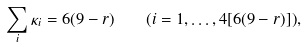<formula> <loc_0><loc_0><loc_500><loc_500>\sum _ { i } \kappa _ { i } = 6 ( 9 - r ) \quad ( i = 1 , \dots , 4 [ 6 ( 9 - r ) ] ) ,</formula> 